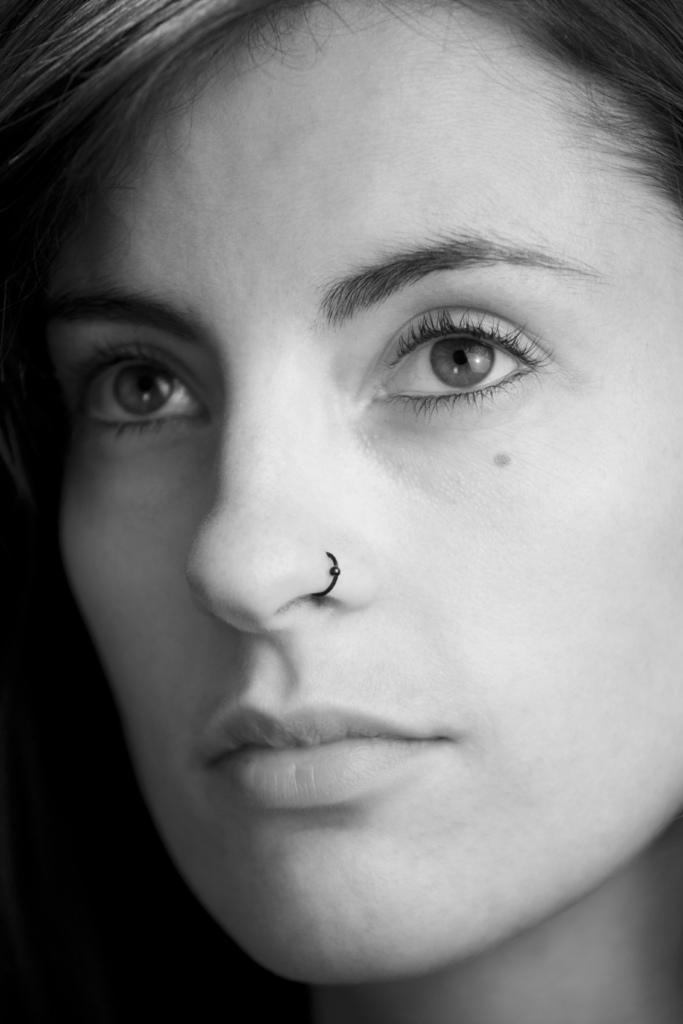What is the focus of the image? The image is a zoomed-in view of a person's head. What facial features can be seen in the image? The person has hairs, eyebrows, eyes, a nose, and a mouth. Are there any accessories visible in the image? Yes, the person is wearing a nose ring. How many geese are flying in the background of the image? There are no geese or background visible in the image, as it is a zoomed-in view of a person's head. What type of pencil is the person holding in the image? There is no pencil present in the image; it is a close-up of a person's head. 